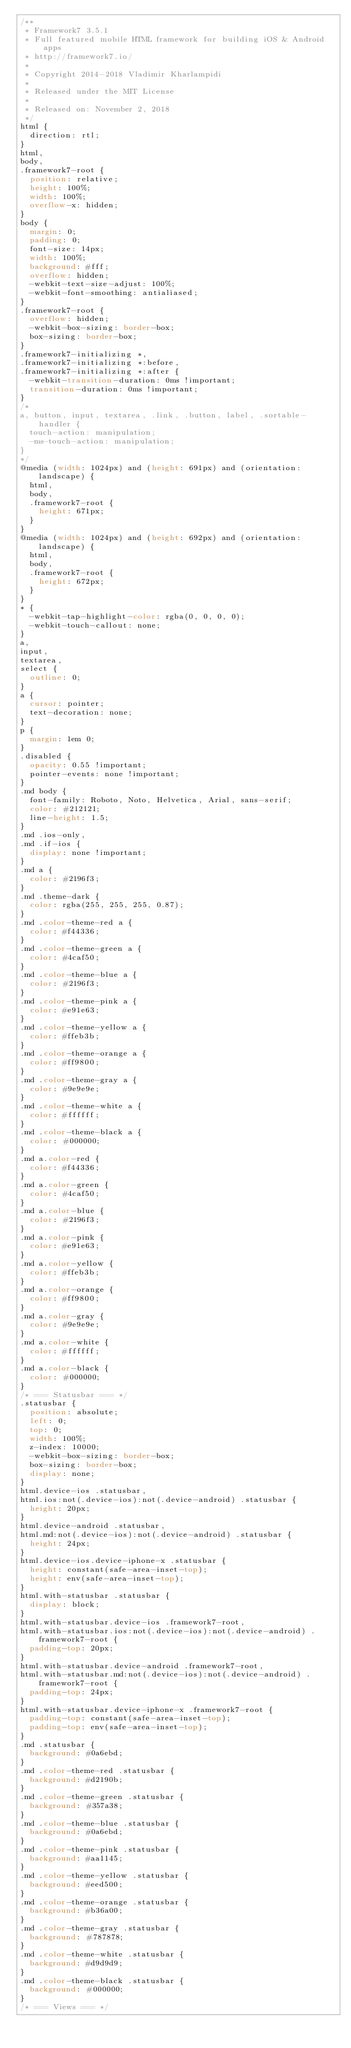Convert code to text. <code><loc_0><loc_0><loc_500><loc_500><_CSS_>/**
 * Framework7 3.5.1
 * Full featured mobile HTML framework for building iOS & Android apps
 * http://framework7.io/
 *
 * Copyright 2014-2018 Vladimir Kharlampidi
 *
 * Released under the MIT License
 *
 * Released on: November 2, 2018
 */
html {
  direction: rtl;
}
html,
body,
.framework7-root {
  position: relative;
  height: 100%;
  width: 100%;
  overflow-x: hidden;
}
body {
  margin: 0;
  padding: 0;
  font-size: 14px;
  width: 100%;
  background: #fff;
  overflow: hidden;
  -webkit-text-size-adjust: 100%;
  -webkit-font-smoothing: antialiased;
}
.framework7-root {
  overflow: hidden;
  -webkit-box-sizing: border-box;
  box-sizing: border-box;
}
.framework7-initializing *,
.framework7-initializing *:before,
.framework7-initializing *:after {
  -webkit-transition-duration: 0ms !important;
  transition-duration: 0ms !important;
}
/*
a, button, input, textarea, .link, .button, label, .sortable-handler {
  touch-action: manipulation;
  -ms-touch-action: manipulation;
}
*/
@media (width: 1024px) and (height: 691px) and (orientation: landscape) {
  html,
  body,
  .framework7-root {
    height: 671px;
  }
}
@media (width: 1024px) and (height: 692px) and (orientation: landscape) {
  html,
  body,
  .framework7-root {
    height: 672px;
  }
}
* {
  -webkit-tap-highlight-color: rgba(0, 0, 0, 0);
  -webkit-touch-callout: none;
}
a,
input,
textarea,
select {
  outline: 0;
}
a {
  cursor: pointer;
  text-decoration: none;
}
p {
  margin: 1em 0;
}
.disabled {
  opacity: 0.55 !important;
  pointer-events: none !important;
}
.md body {
  font-family: Roboto, Noto, Helvetica, Arial, sans-serif;
  color: #212121;
  line-height: 1.5;
}
.md .ios-only,
.md .if-ios {
  display: none !important;
}
.md a {
  color: #2196f3;
}
.md .theme-dark {
  color: rgba(255, 255, 255, 0.87);
}
.md .color-theme-red a {
  color: #f44336;
}
.md .color-theme-green a {
  color: #4caf50;
}
.md .color-theme-blue a {
  color: #2196f3;
}
.md .color-theme-pink a {
  color: #e91e63;
}
.md .color-theme-yellow a {
  color: #ffeb3b;
}
.md .color-theme-orange a {
  color: #ff9800;
}
.md .color-theme-gray a {
  color: #9e9e9e;
}
.md .color-theme-white a {
  color: #ffffff;
}
.md .color-theme-black a {
  color: #000000;
}
.md a.color-red {
  color: #f44336;
}
.md a.color-green {
  color: #4caf50;
}
.md a.color-blue {
  color: #2196f3;
}
.md a.color-pink {
  color: #e91e63;
}
.md a.color-yellow {
  color: #ffeb3b;
}
.md a.color-orange {
  color: #ff9800;
}
.md a.color-gray {
  color: #9e9e9e;
}
.md a.color-white {
  color: #ffffff;
}
.md a.color-black {
  color: #000000;
}
/* === Statusbar === */
.statusbar {
  position: absolute;
  left: 0;
  top: 0;
  width: 100%;
  z-index: 10000;
  -webkit-box-sizing: border-box;
  box-sizing: border-box;
  display: none;
}
html.device-ios .statusbar,
html.ios:not(.device-ios):not(.device-android) .statusbar {
  height: 20px;
}
html.device-android .statusbar,
html.md:not(.device-ios):not(.device-android) .statusbar {
  height: 24px;
}
html.device-ios.device-iphone-x .statusbar {
  height: constant(safe-area-inset-top);
  height: env(safe-area-inset-top);
}
html.with-statusbar .statusbar {
  display: block;
}
html.with-statusbar.device-ios .framework7-root,
html.with-statusbar.ios:not(.device-ios):not(.device-android) .framework7-root {
  padding-top: 20px;
}
html.with-statusbar.device-android .framework7-root,
html.with-statusbar.md:not(.device-ios):not(.device-android) .framework7-root {
  padding-top: 24px;
}
html.with-statusbar.device-iphone-x .framework7-root {
  padding-top: constant(safe-area-inset-top);
  padding-top: env(safe-area-inset-top);
}
.md .statusbar {
  background: #0a6ebd;
}
.md .color-theme-red .statusbar {
  background: #d2190b;
}
.md .color-theme-green .statusbar {
  background: #357a38;
}
.md .color-theme-blue .statusbar {
  background: #0a6ebd;
}
.md .color-theme-pink .statusbar {
  background: #aa1145;
}
.md .color-theme-yellow .statusbar {
  background: #eed500;
}
.md .color-theme-orange .statusbar {
  background: #b36a00;
}
.md .color-theme-gray .statusbar {
  background: #787878;
}
.md .color-theme-white .statusbar {
  background: #d9d9d9;
}
.md .color-theme-black .statusbar {
  background: #000000;
}
/* === Views === */</code> 